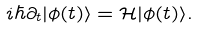<formula> <loc_0><loc_0><loc_500><loc_500>i \hbar { \partial } _ { t } | \phi ( t ) \rangle = \mathcal { H } | \phi ( t ) \rangle .</formula> 